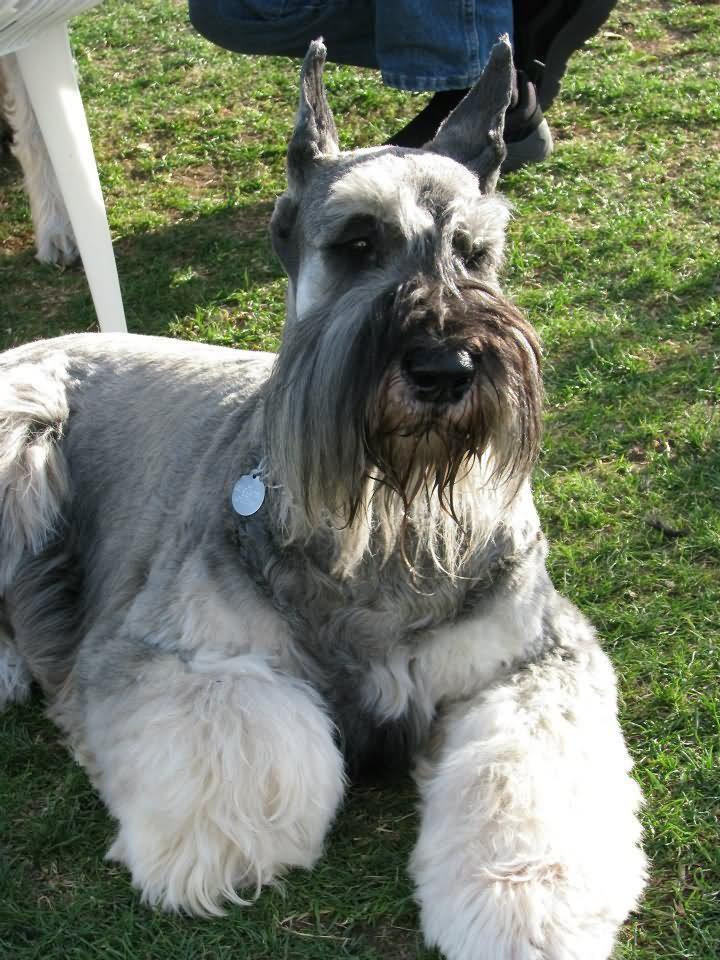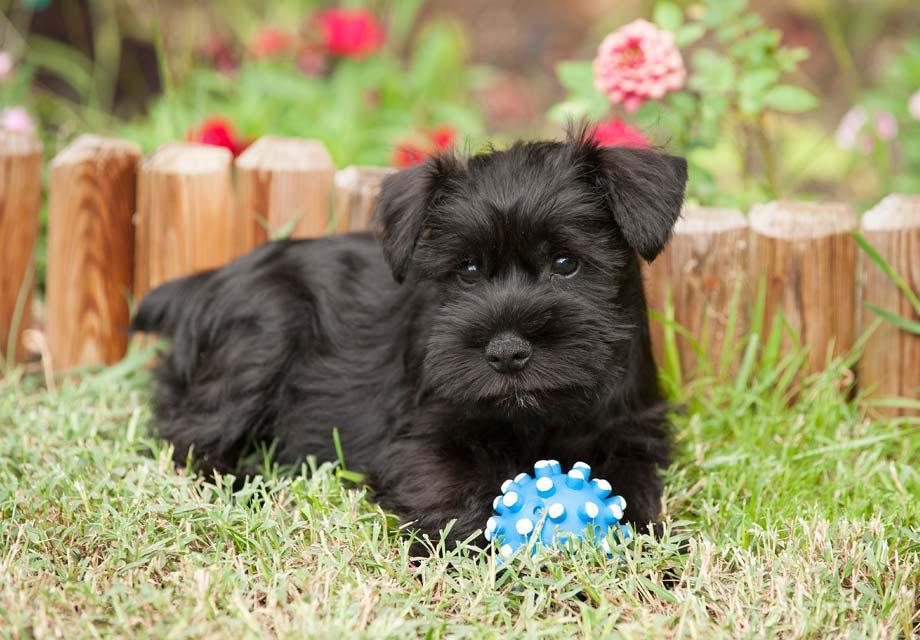The first image is the image on the left, the second image is the image on the right. Considering the images on both sides, is "Right image shows a schnauzer in a collar standing facing leftward." valid? Answer yes or no. No. The first image is the image on the left, the second image is the image on the right. Analyze the images presented: Is the assertion "In one image, a dog standing with legs straight and tail curled up is wearing a red collar." valid? Answer yes or no. No. 